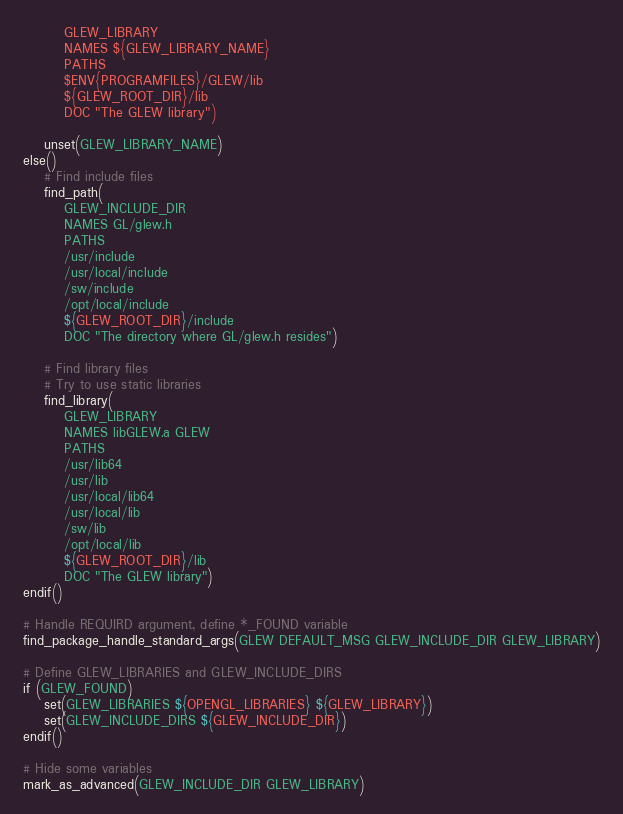<code> <loc_0><loc_0><loc_500><loc_500><_CMake_>		GLEW_LIBRARY
		NAMES ${GLEW_LIBRARY_NAME}
		PATHS
		$ENV{PROGRAMFILES}/GLEW/lib
		${GLEW_ROOT_DIR}/lib
		DOC "The GLEW library")

	unset(GLEW_LIBRARY_NAME)
else()
	# Find include files
	find_path(
		GLEW_INCLUDE_DIR
		NAMES GL/glew.h
		PATHS
		/usr/include
		/usr/local/include
		/sw/include
		/opt/local/include
		${GLEW_ROOT_DIR}/include
		DOC "The directory where GL/glew.h resides")

	# Find library files
	# Try to use static libraries
	find_library(
		GLEW_LIBRARY
		NAMES libGLEW.a GLEW
		PATHS
		/usr/lib64
		/usr/lib
		/usr/local/lib64
		/usr/local/lib
		/sw/lib
		/opt/local/lib
		${GLEW_ROOT_DIR}/lib
		DOC "The GLEW library")
endif()

# Handle REQUIRD argument, define *_FOUND variable
find_package_handle_standard_args(GLEW DEFAULT_MSG GLEW_INCLUDE_DIR GLEW_LIBRARY)

# Define GLEW_LIBRARIES and GLEW_INCLUDE_DIRS
if (GLEW_FOUND)
	set(GLEW_LIBRARIES ${OPENGL_LIBRARIES} ${GLEW_LIBRARY})
	set(GLEW_INCLUDE_DIRS ${GLEW_INCLUDE_DIR})
endif()

# Hide some variables
mark_as_advanced(GLEW_INCLUDE_DIR GLEW_LIBRARY)
</code> 